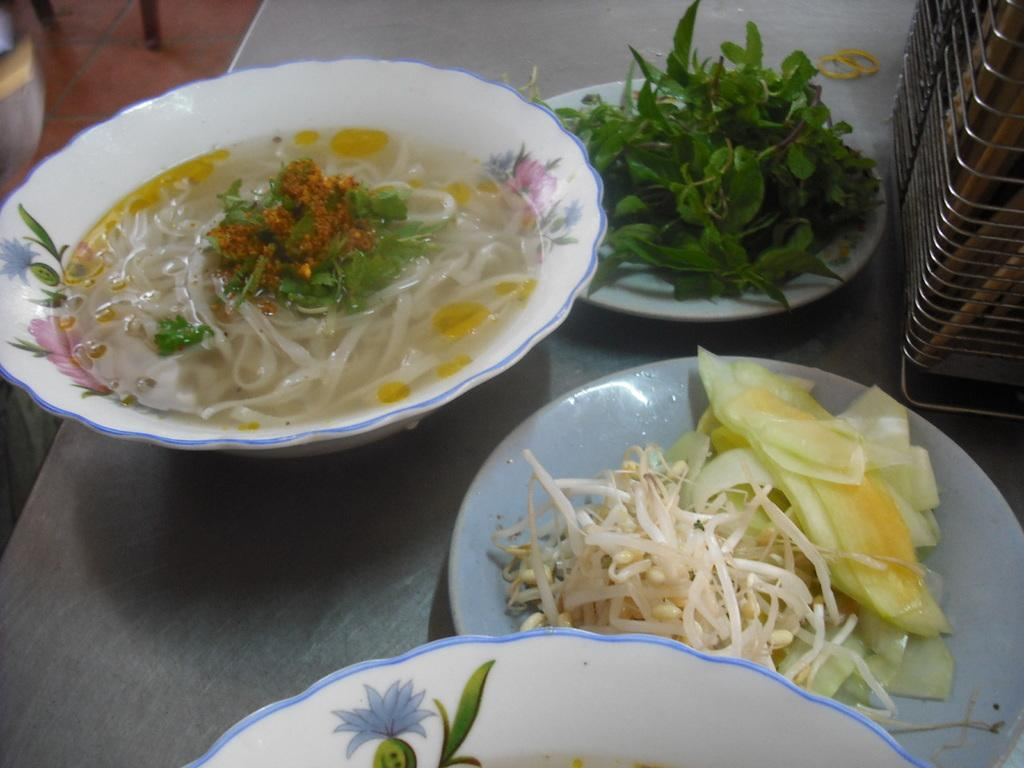What is in the bowls that are visible in the image? There are bowls with food in the image. What else can be seen on the plates in the image? There are plates with veggies and leaves in the image. What is the purpose of the stand on the table in the image? The stand on the table in the image is likely used to hold or display items. What type of apparel is being worn by the food in the image? There is no apparel present in the image, as the subjects are food and plates. 